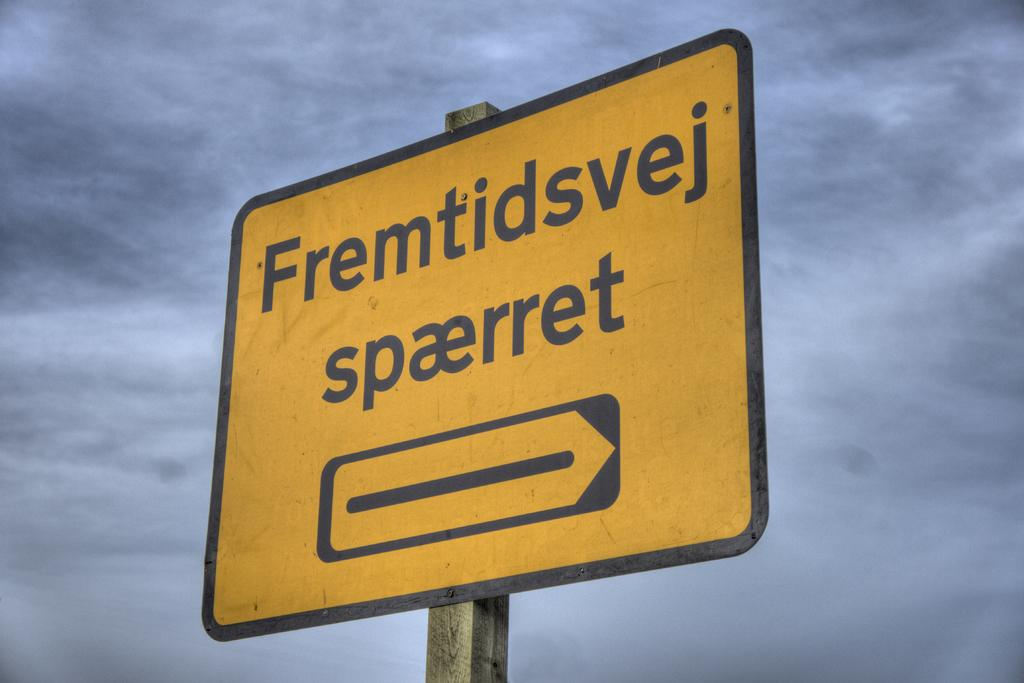<image>
Summarize the visual content of the image. A square yellow sign with an arrow that says fremtidsvej. 